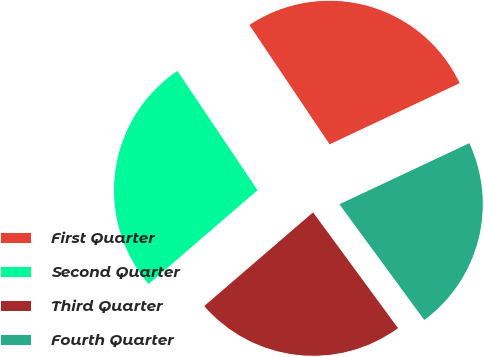Convert chart to OTSL. <chart><loc_0><loc_0><loc_500><loc_500><pie_chart><fcel>First Quarter<fcel>Second Quarter<fcel>Third Quarter<fcel>Fourth Quarter<nl><fcel>27.42%<fcel>26.9%<fcel>23.76%<fcel>21.92%<nl></chart> 